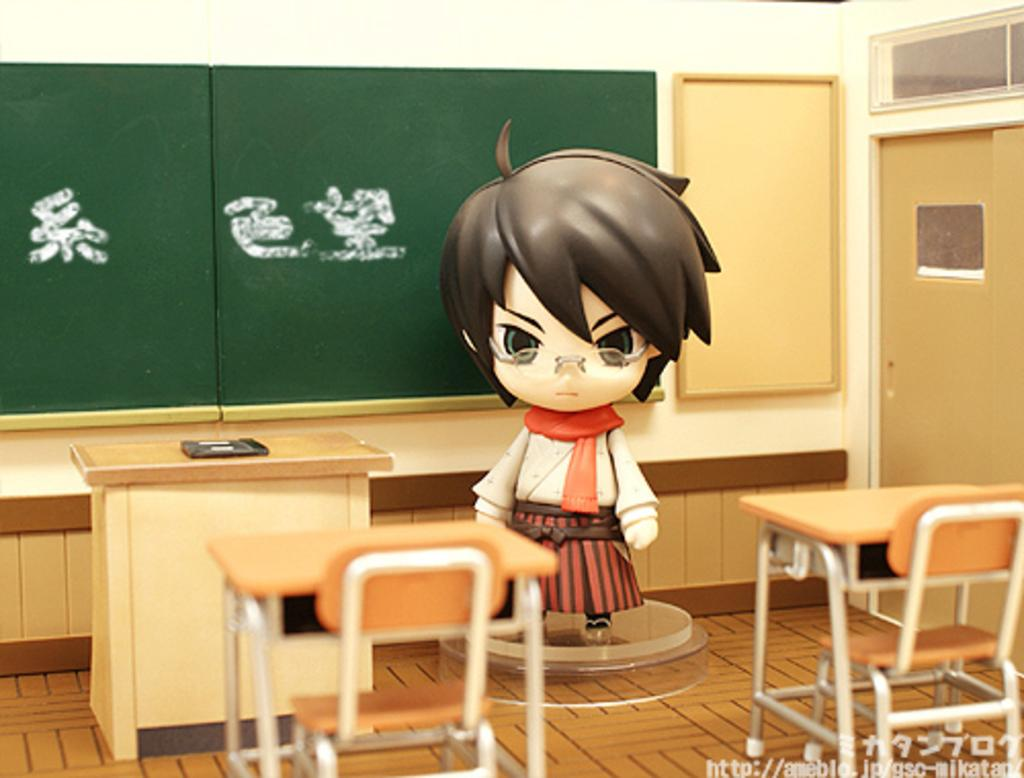Where is the toy located in the image? The toy is standing on a dias in the image. What other objects can be seen in the image besides the toy? There is a board, a desk, tables, chairs, and a door in the image. Can you describe the furniture in the image? There is a desk and tables in the image, along with chairs. What type of opening is present in the image? There is a door in the image. Can you see a pet sitting on the chair in the image? There is no pet visible in the image. How many ladybugs are crawling on the board in the image? There are no ladybugs present in the image. 